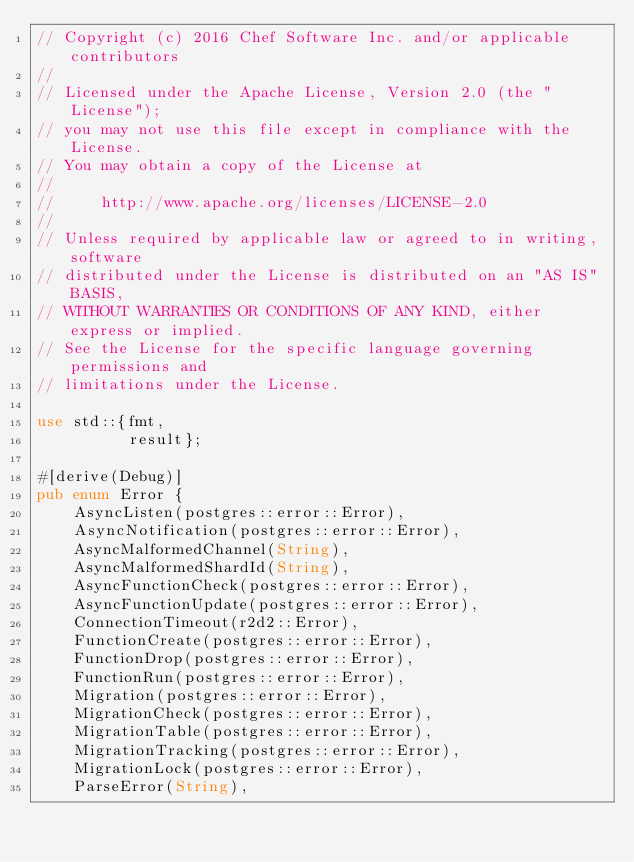<code> <loc_0><loc_0><loc_500><loc_500><_Rust_>// Copyright (c) 2016 Chef Software Inc. and/or applicable contributors
//
// Licensed under the Apache License, Version 2.0 (the "License");
// you may not use this file except in compliance with the License.
// You may obtain a copy of the License at
//
//     http://www.apache.org/licenses/LICENSE-2.0
//
// Unless required by applicable law or agreed to in writing, software
// distributed under the License is distributed on an "AS IS" BASIS,
// WITHOUT WARRANTIES OR CONDITIONS OF ANY KIND, either express or implied.
// See the License for the specific language governing permissions and
// limitations under the License.

use std::{fmt,
          result};

#[derive(Debug)]
pub enum Error {
    AsyncListen(postgres::error::Error),
    AsyncNotification(postgres::error::Error),
    AsyncMalformedChannel(String),
    AsyncMalformedShardId(String),
    AsyncFunctionCheck(postgres::error::Error),
    AsyncFunctionUpdate(postgres::error::Error),
    ConnectionTimeout(r2d2::Error),
    FunctionCreate(postgres::error::Error),
    FunctionDrop(postgres::error::Error),
    FunctionRun(postgres::error::Error),
    Migration(postgres::error::Error),
    MigrationCheck(postgres::error::Error),
    MigrationTable(postgres::error::Error),
    MigrationTracking(postgres::error::Error),
    MigrationLock(postgres::error::Error),
    ParseError(String),</code> 